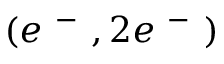<formula> <loc_0><loc_0><loc_500><loc_500>( e ^ { - } , 2 e ^ { - } )</formula> 